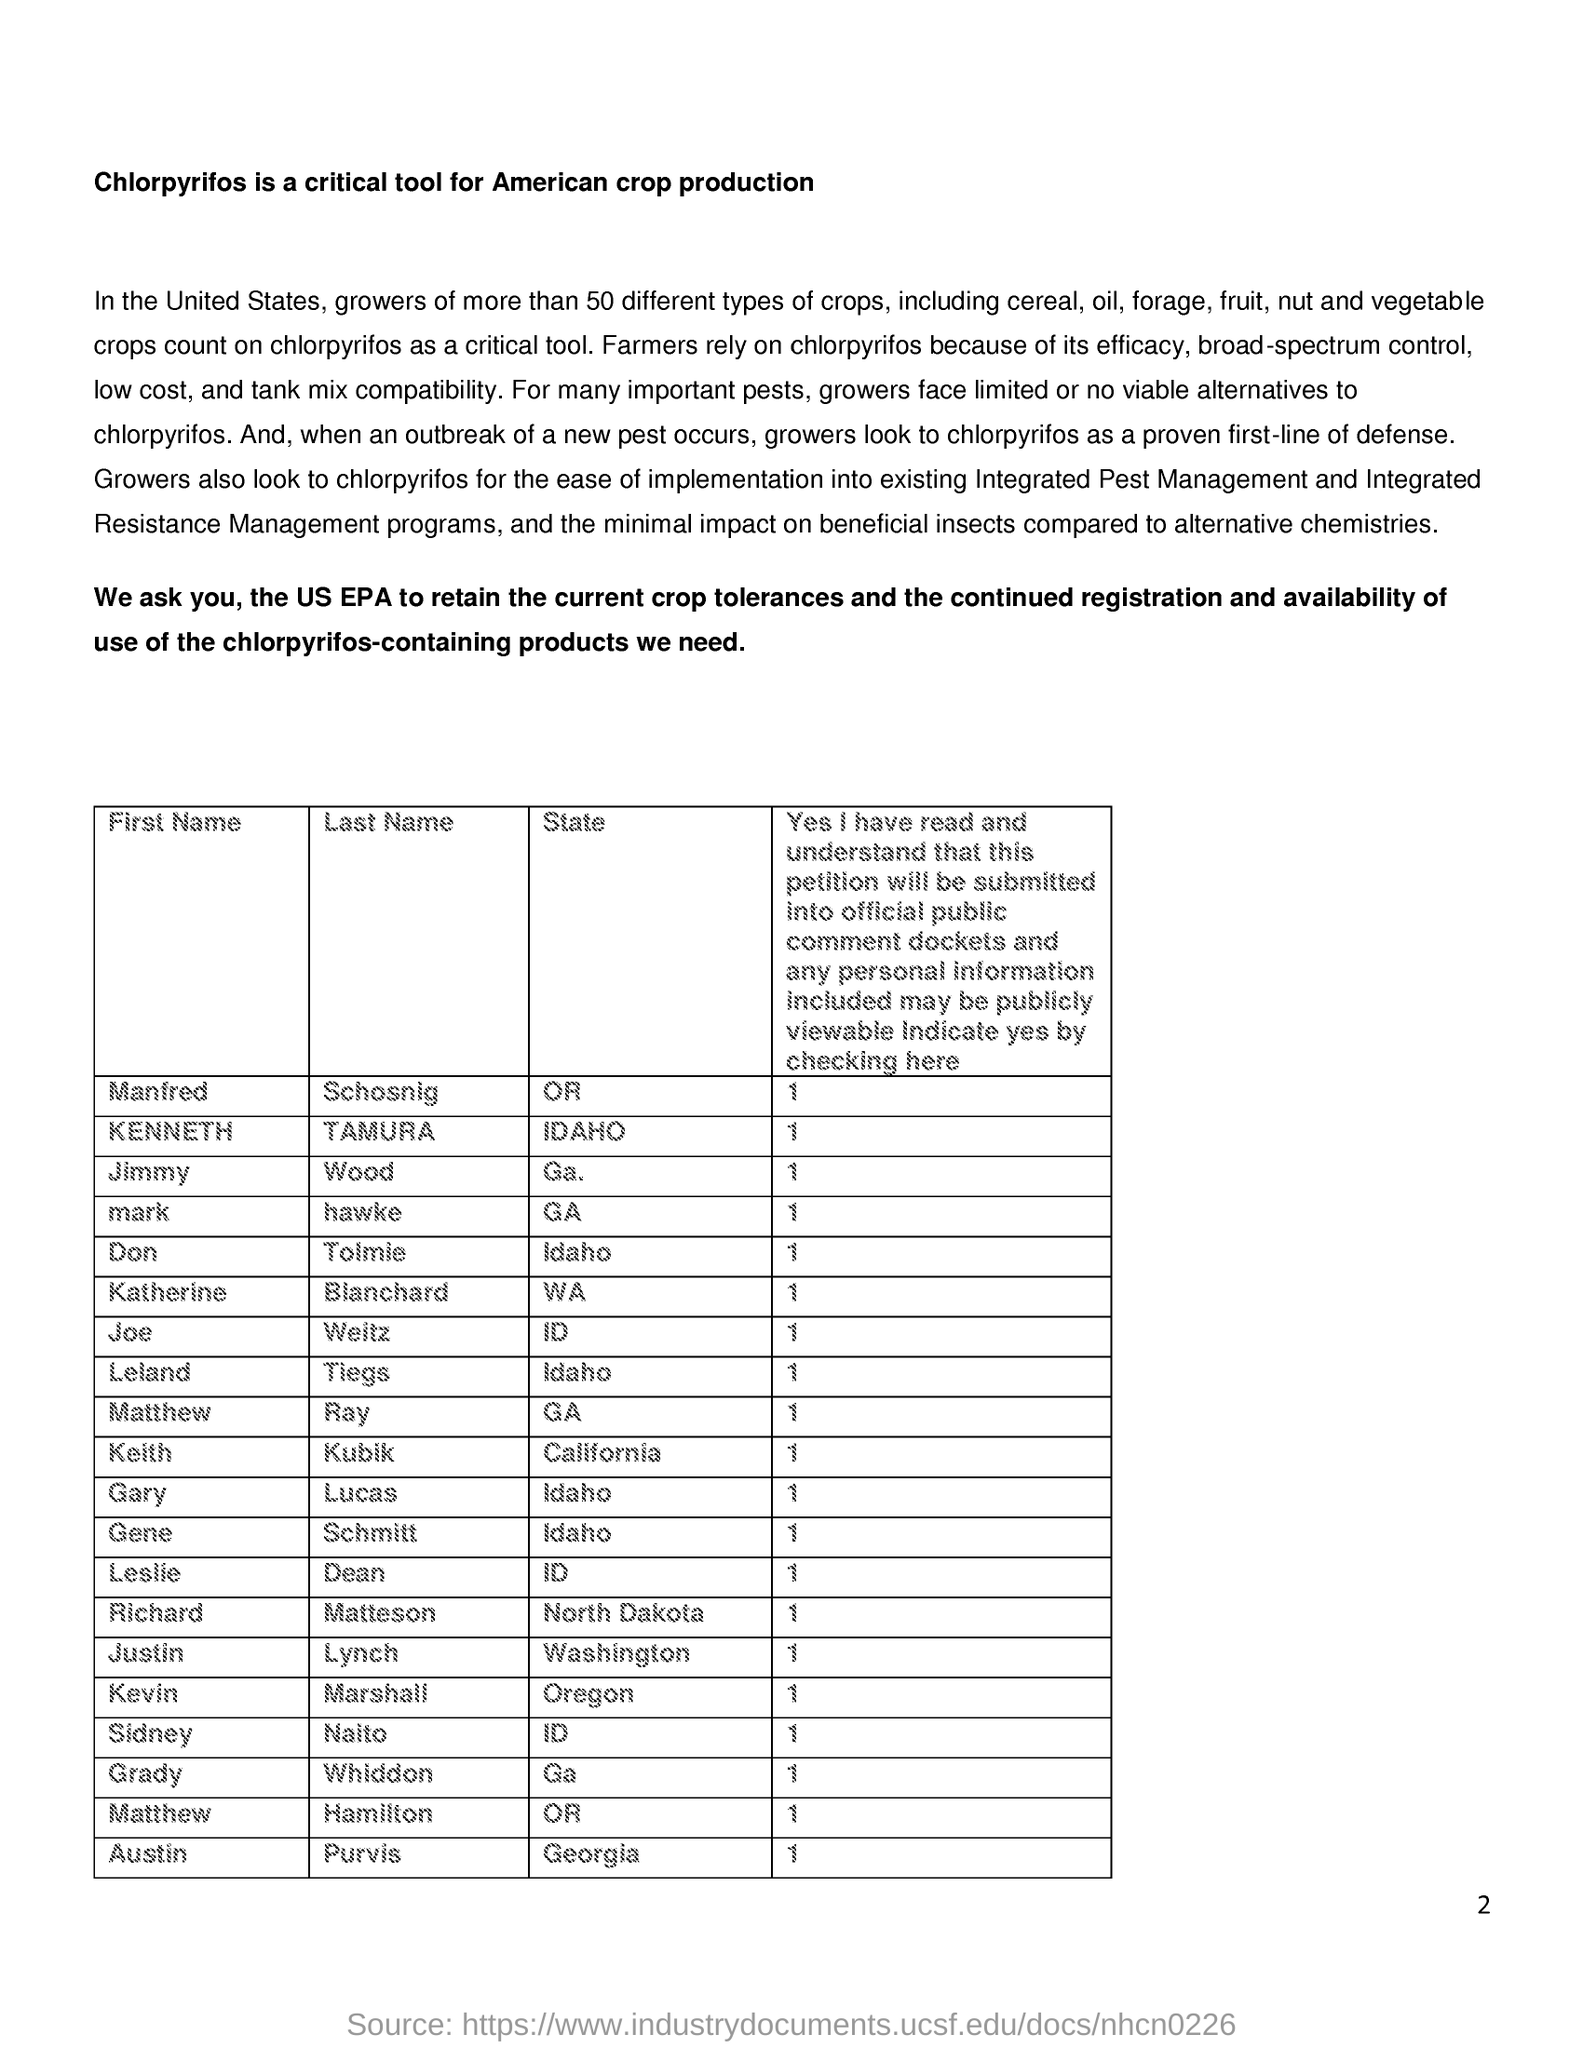Outline some significant characteristics in this image. Farmers rely on Chlorpyrifos due to its effectiveness, broad spectrum control, affordability, and compatibility with other pesticides in tank mixtures. When an outbreak of a new pest occurs, growers often turn to chlorpyrifos as a control measure. Chlorpyrifos is a critical tool utilized for American crop production, playing a crucial role in ensuring the success of agricultural endeavors. Justin Lynch is a resident of the state of Washington. 